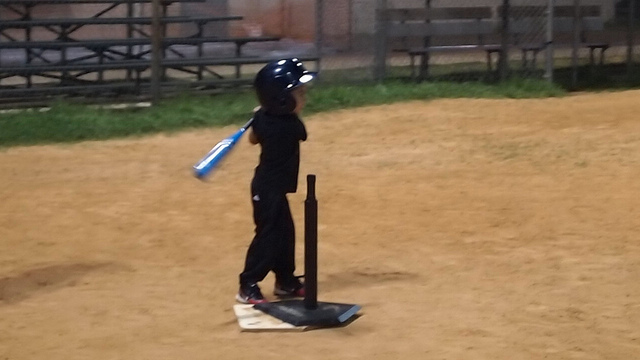Who would the child be more likely to admire?
A. wayne gretzky
B. tiger woods
C. pete alonso
D. pele
Answer with the option's letter from the given choices directly. Given that the child is depicted on a baseball diamond, wearing a batting helmet and holding a baseball bat, it is likely that they would most admire a baseball player. Therefore, the most appropriate answer is C. Pete Alonso, a renowned baseball player, which aligns with the context of the image and the sport that the child is currently engaged in. It's important to acknowledge that a child's admiration can also be influenced by personal exposure to sports, family preferences, and local sports culture. 